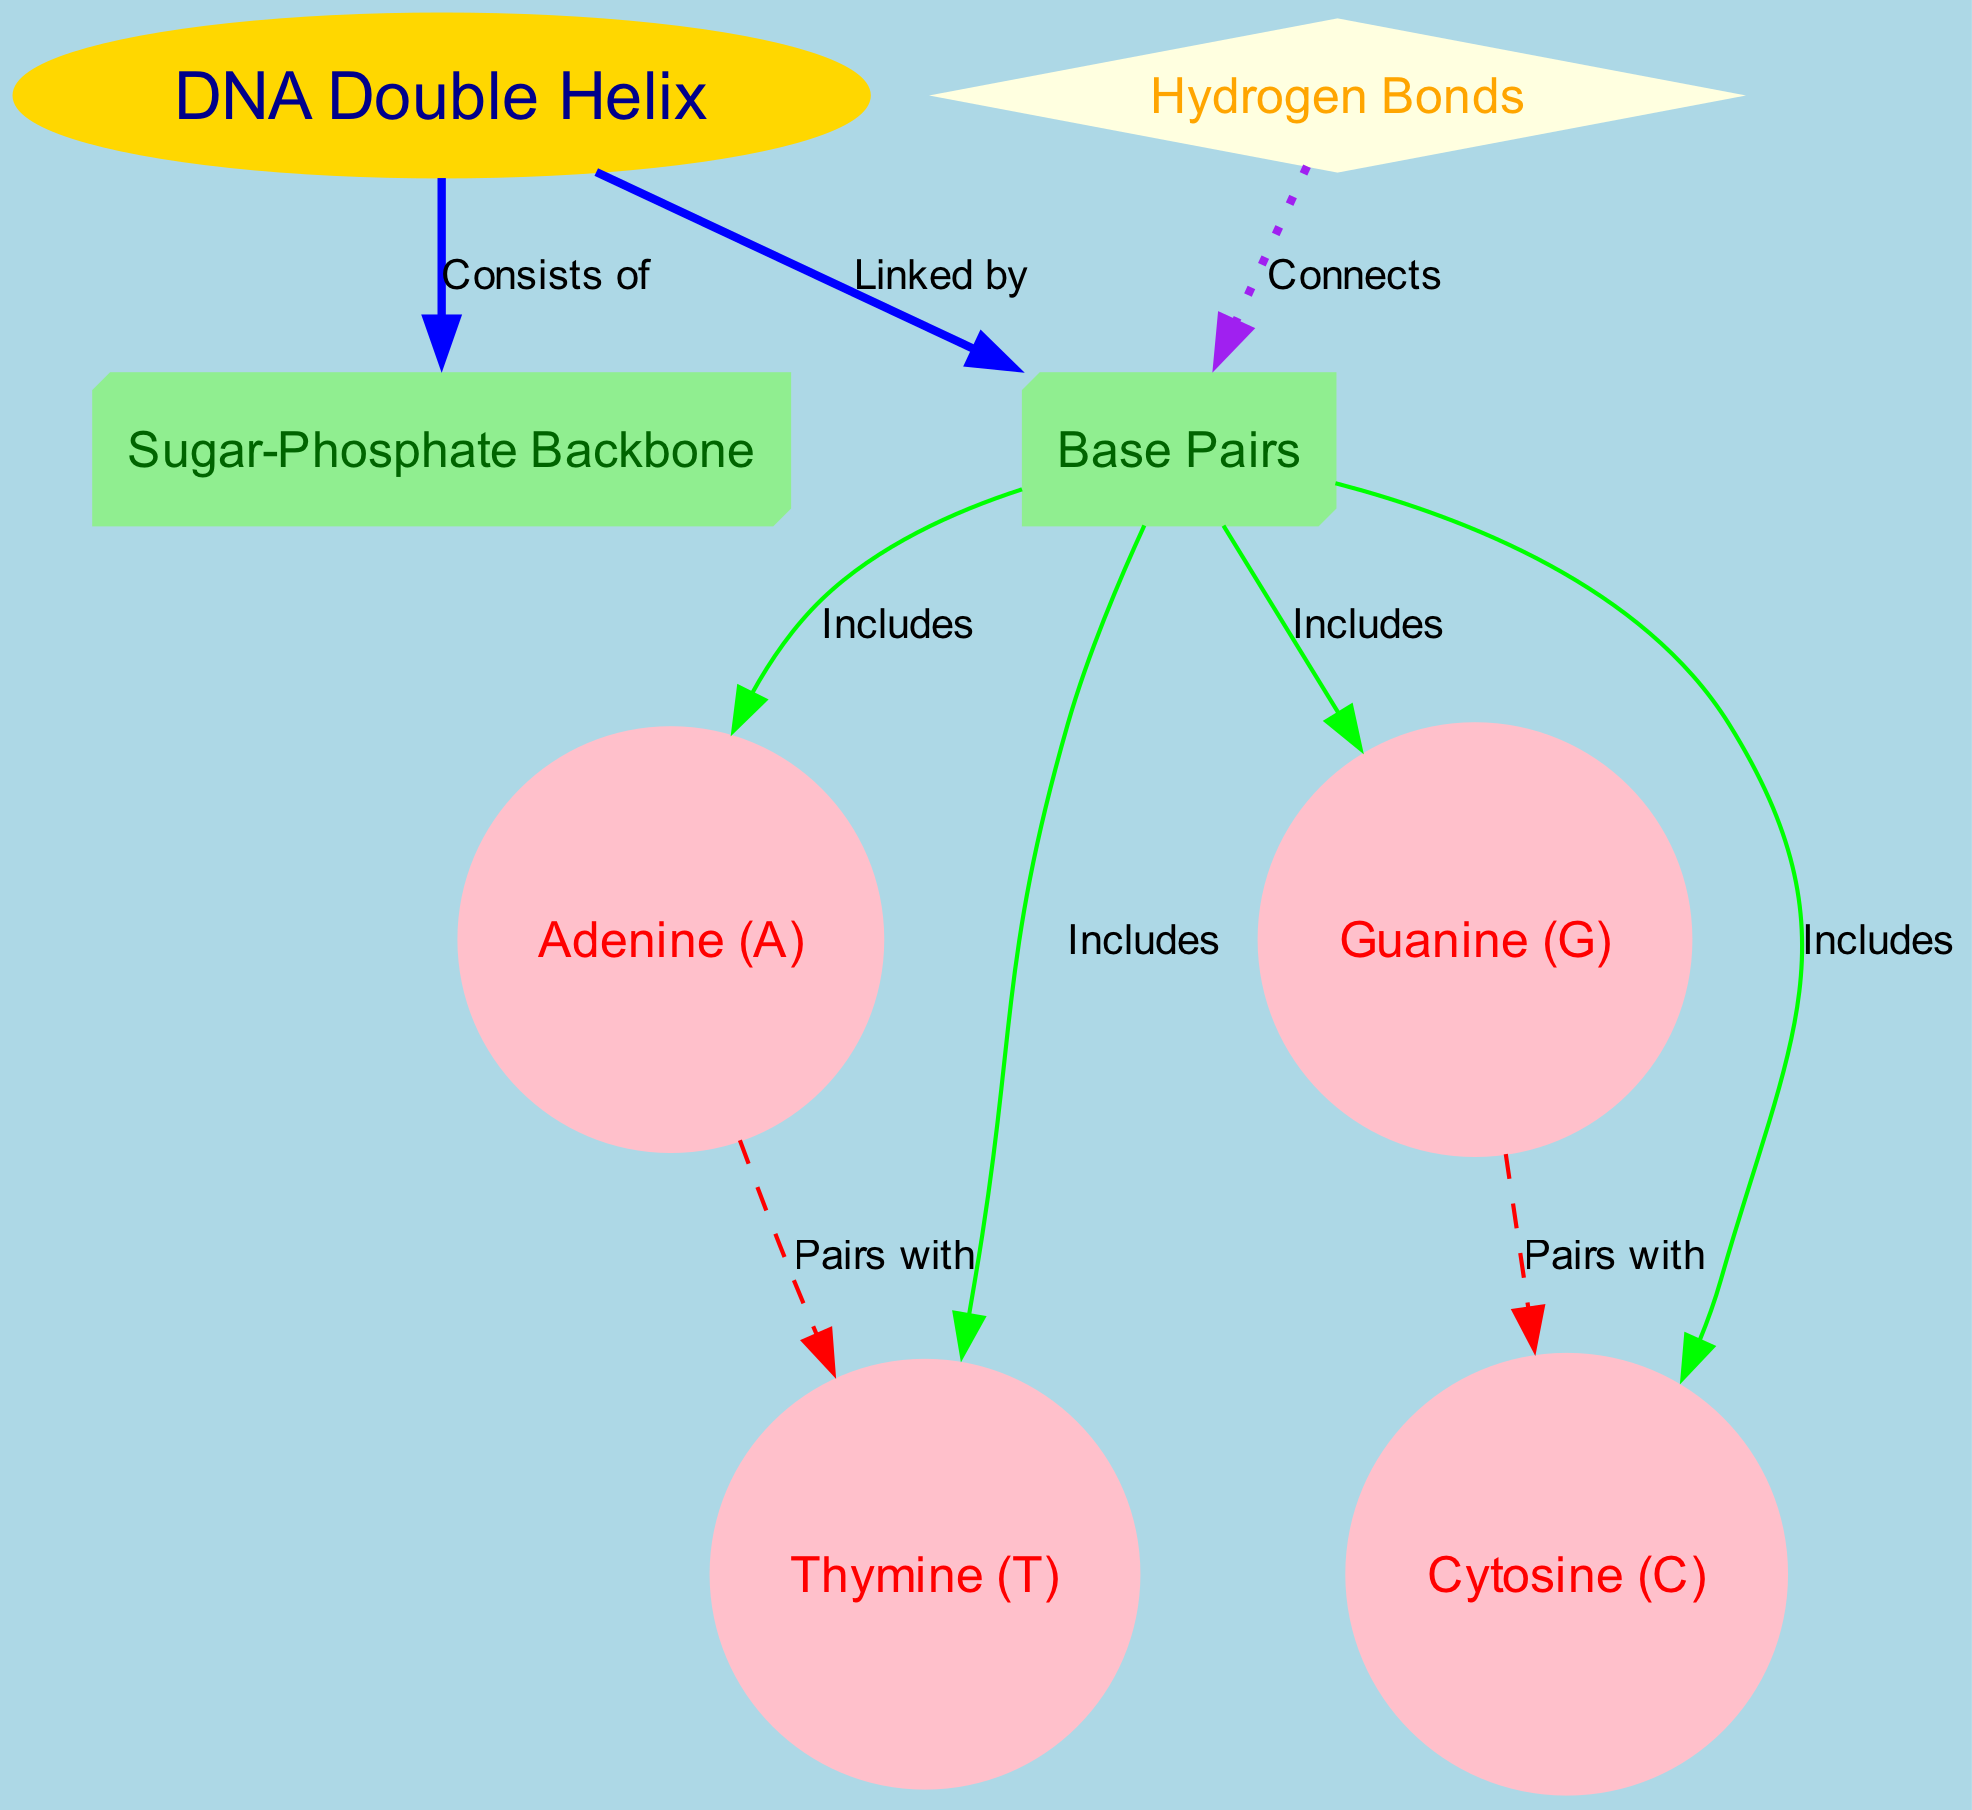What does the DNA double helix consist of? The diagram indicates that the DNA double helix consists of the Sugar-Phosphate Backbone. This is represented as a direct edge linked from the DNA node to the backbone node labeled "Consists of."
Answer: Sugar-Phosphate Backbone How many base pairs are included in the diagram? The diagram shows that there are four base pairs: Adenine, Thymine, Guanine, and Cytosine. Each of these base pairs is linked to the base pairs node with an "Includes" label, indicating their total count is four.
Answer: Four Which base pairs are connected by hydrogen bonds? According to the diagram, hydrogen bonds connect Adenine with Thymine and Guanine with Cytosine. The connections are indicated by the edges labeled "Pairs with," showing the specific pairing relationship.
Answer: Adenine and Thymine, Guanine and Cytosine What color represents the DNA double helix in the diagram? The DNA double helix is represented by an oval shape and is colored gold as specified in the node attributes of the diagram. This is visually distinct from the other nodes, allowing for easy identification.
Answer: Gold What links the base pairs in the diagram? The diagram explicitly states that the base pairs are connected by Hydrogen Bonds. This is indicated by the edge labeled "Connects" that originates from the hydrogen node towards the base pairs node.
Answer: Hydrogen Bonds How do Adenine and Thymine relate in the structure of DNA? The diagram shows that Adenine pairs with Thymine as indicated by the edge labeled "Pairs with." This relationship displays their complementary nature in the structure of DNA.
Answer: Pairs with 